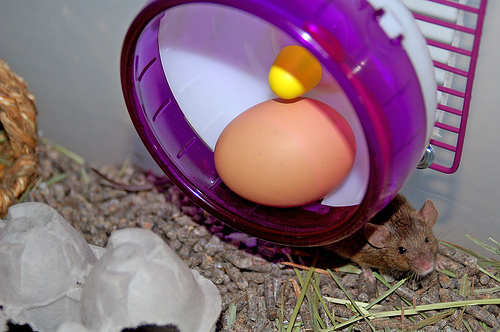<image>
Is there a egg behind the rat? No. The egg is not behind the rat. From this viewpoint, the egg appears to be positioned elsewhere in the scene. Where is the egg in relation to the hamster wheel? Is it in the hamster wheel? Yes. The egg is contained within or inside the hamster wheel, showing a containment relationship. Is there a egg in the wheel? Yes. The egg is contained within or inside the wheel, showing a containment relationship. Where is the egg in relation to the hamster? Is it above the hamster? Yes. The egg is positioned above the hamster in the vertical space, higher up in the scene. 